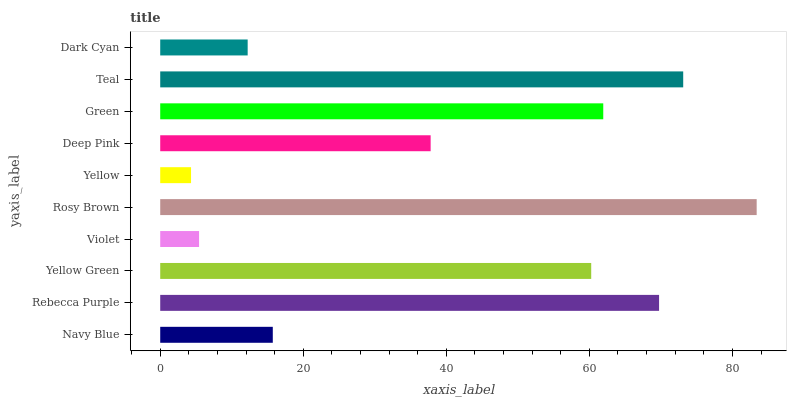Is Yellow the minimum?
Answer yes or no. Yes. Is Rosy Brown the maximum?
Answer yes or no. Yes. Is Rebecca Purple the minimum?
Answer yes or no. No. Is Rebecca Purple the maximum?
Answer yes or no. No. Is Rebecca Purple greater than Navy Blue?
Answer yes or no. Yes. Is Navy Blue less than Rebecca Purple?
Answer yes or no. Yes. Is Navy Blue greater than Rebecca Purple?
Answer yes or no. No. Is Rebecca Purple less than Navy Blue?
Answer yes or no. No. Is Yellow Green the high median?
Answer yes or no. Yes. Is Deep Pink the low median?
Answer yes or no. Yes. Is Rosy Brown the high median?
Answer yes or no. No. Is Yellow the low median?
Answer yes or no. No. 